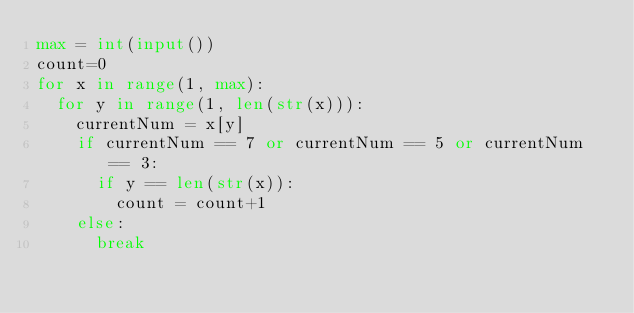<code> <loc_0><loc_0><loc_500><loc_500><_Python_>max = int(input())
count=0
for x in range(1, max):
  for y in range(1, len(str(x))):
    currentNum = x[y]
    if currentNum == 7 or currentNum == 5 or currentNum == 3:
      if y == len(str(x)):
        count = count+1
    else:
      break</code> 